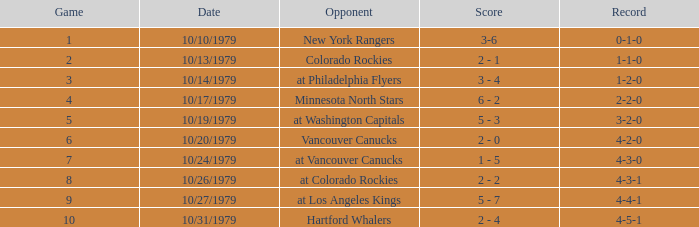On which date is the record 4-3-0? 10/24/1979. 